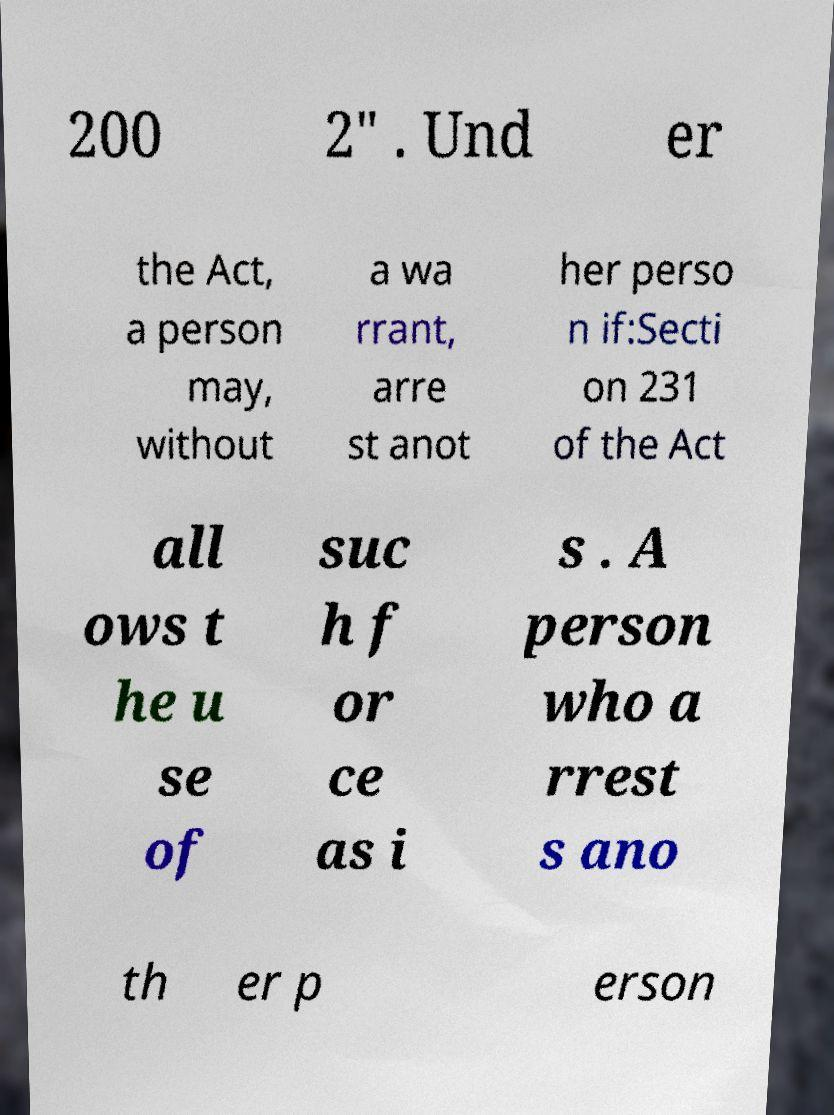For documentation purposes, I need the text within this image transcribed. Could you provide that? 200 2" . Und er the Act, a person may, without a wa rrant, arre st anot her perso n if:Secti on 231 of the Act all ows t he u se of suc h f or ce as i s . A person who a rrest s ano th er p erson 